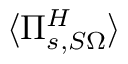Convert formula to latex. <formula><loc_0><loc_0><loc_500><loc_500>\langle \Pi _ { s , S \Omega } ^ { H } \rangle</formula> 